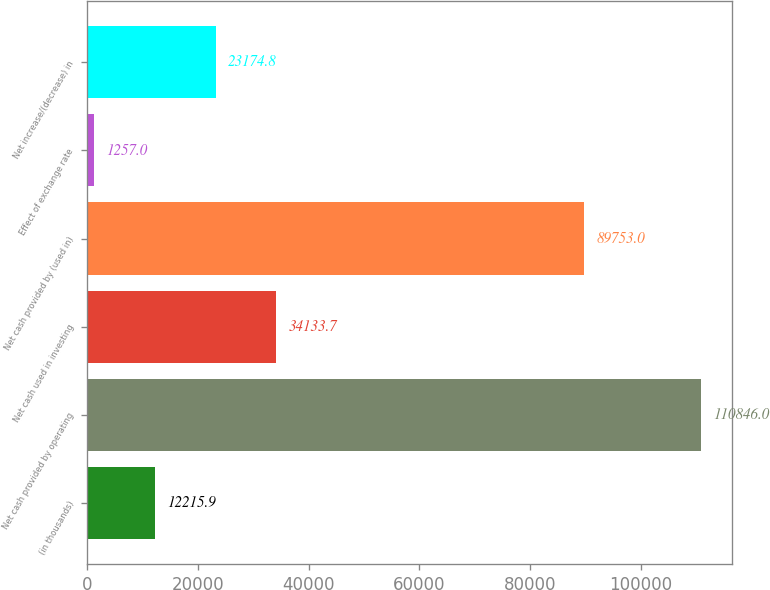Convert chart to OTSL. <chart><loc_0><loc_0><loc_500><loc_500><bar_chart><fcel>(in thousands)<fcel>Net cash provided by operating<fcel>Net cash used in investing<fcel>Net cash provided by (used in)<fcel>Effect of exchange rate<fcel>Net increase/(decrease) in<nl><fcel>12215.9<fcel>110846<fcel>34133.7<fcel>89753<fcel>1257<fcel>23174.8<nl></chart> 